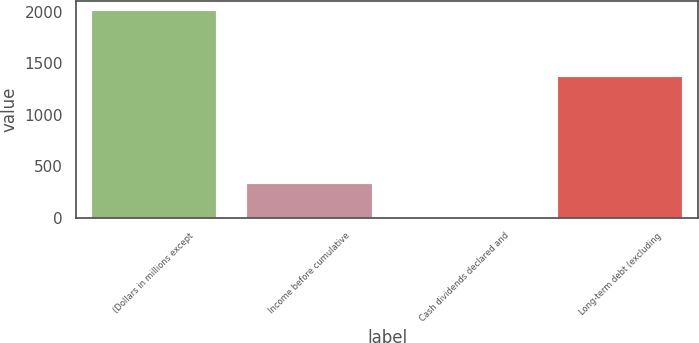Convert chart. <chart><loc_0><loc_0><loc_500><loc_500><bar_chart><fcel>(Dollars in millions except<fcel>Income before cumulative<fcel>Cash dividends declared and<fcel>Long-term debt (excluding<nl><fcel>2005<fcel>324.91<fcel>1.68<fcel>1368<nl></chart> 